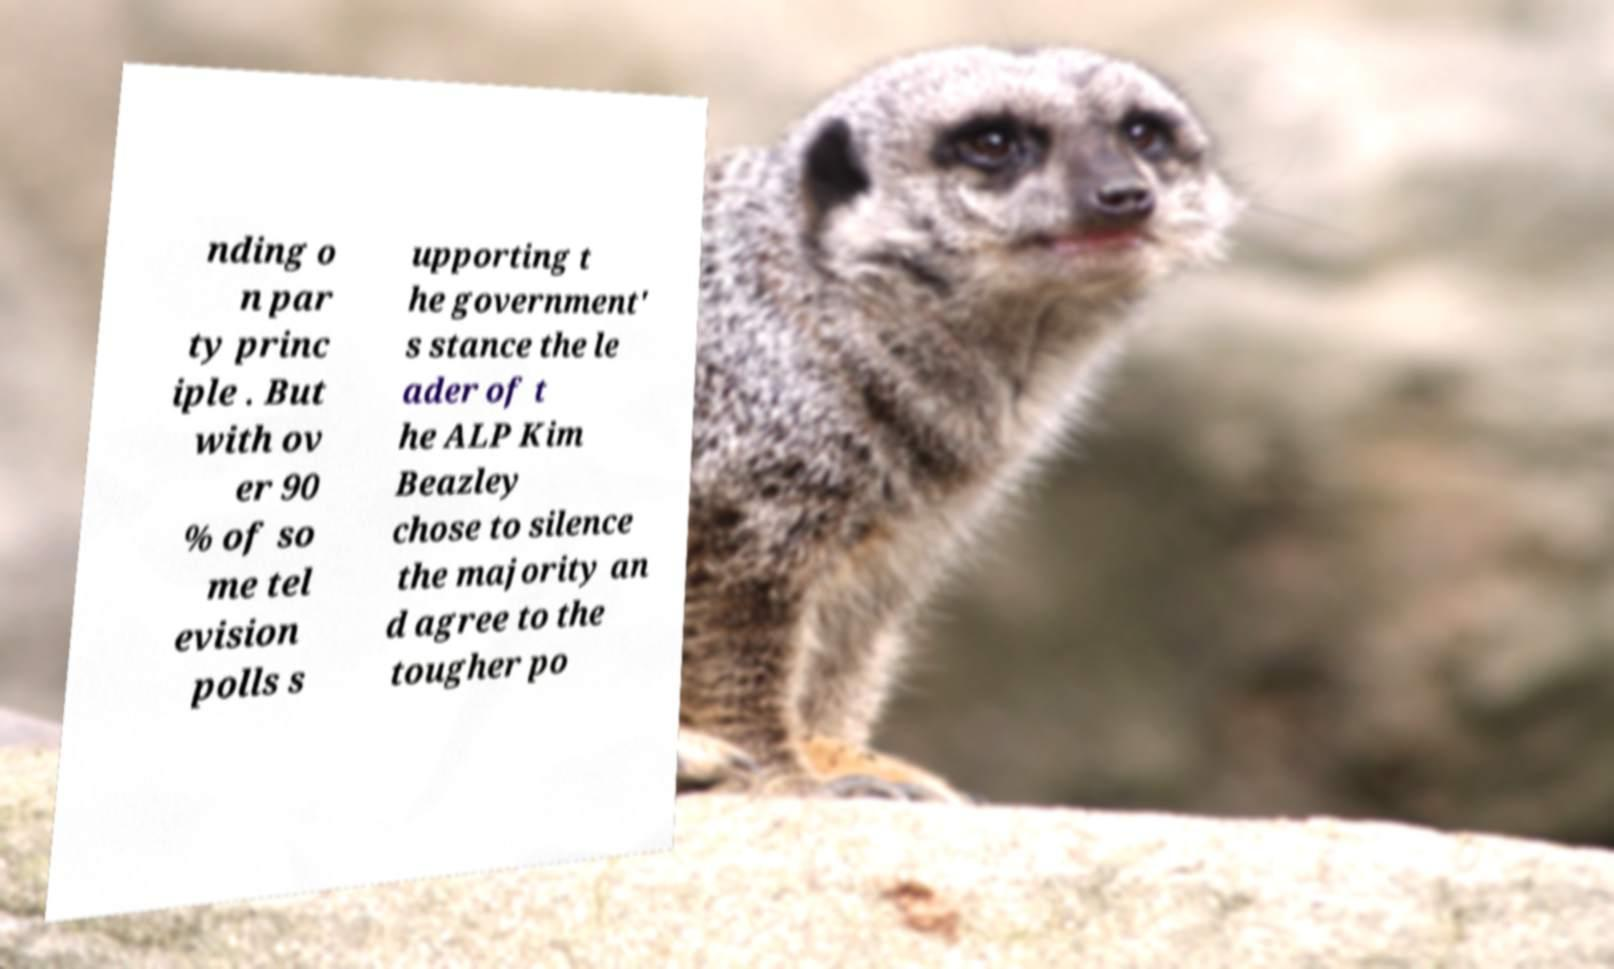There's text embedded in this image that I need extracted. Can you transcribe it verbatim? nding o n par ty princ iple . But with ov er 90 % of so me tel evision polls s upporting t he government' s stance the le ader of t he ALP Kim Beazley chose to silence the majority an d agree to the tougher po 